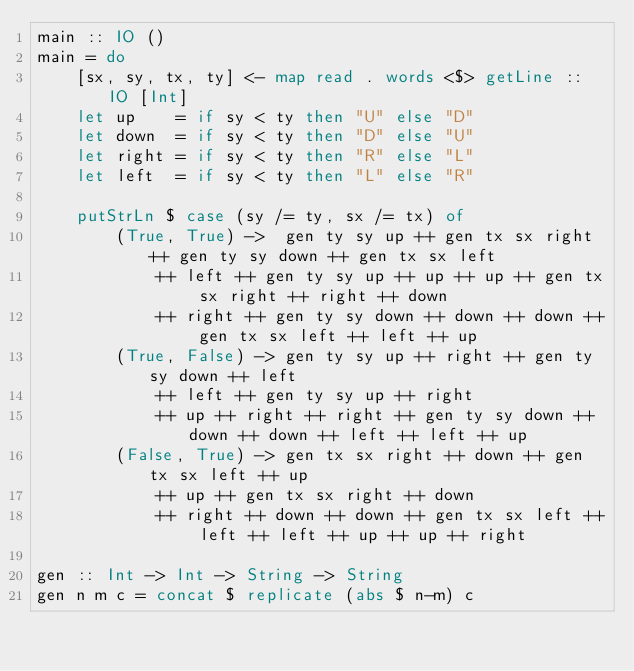<code> <loc_0><loc_0><loc_500><loc_500><_Haskell_>main :: IO ()
main = do
    [sx, sy, tx, ty] <- map read . words <$> getLine :: IO [Int]
    let up    = if sy < ty then "U" else "D"
    let down  = if sy < ty then "D" else "U"
    let right = if sy < ty then "R" else "L"
    let left  = if sy < ty then "L" else "R"

    putStrLn $ case (sy /= ty, sx /= tx) of
        (True, True) ->  gen ty sy up ++ gen tx sx right ++ gen ty sy down ++ gen tx sx left
            ++ left ++ gen ty sy up ++ up ++ up ++ gen tx sx right ++ right ++ down
            ++ right ++ gen ty sy down ++ down ++ down ++ gen tx sx left ++ left ++ up
        (True, False) -> gen ty sy up ++ right ++ gen ty sy down ++ left
            ++ left ++ gen ty sy up ++ right
            ++ up ++ right ++ right ++ gen ty sy down ++ down ++ down ++ left ++ left ++ up
        (False, True) -> gen tx sx right ++ down ++ gen tx sx left ++ up
            ++ up ++ gen tx sx right ++ down
            ++ right ++ down ++ down ++ gen tx sx left ++ left ++ left ++ up ++ up ++ right

gen :: Int -> Int -> String -> String
gen n m c = concat $ replicate (abs $ n-m) c
</code> 